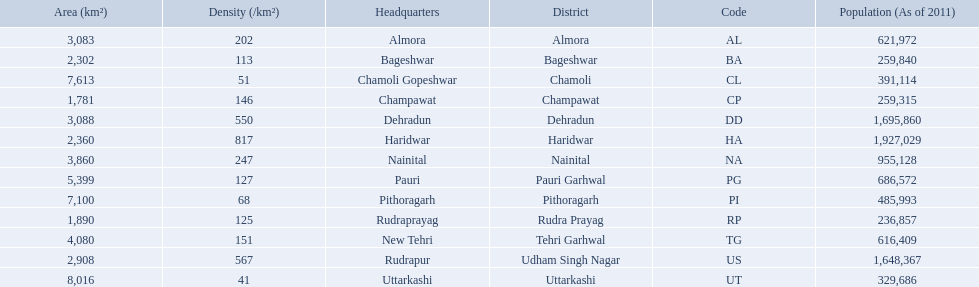What are the values for density of the districts of uttrakhand? 202, 113, 51, 146, 550, 817, 247, 127, 68, 125, 151, 567, 41. Which district has value of 51? Chamoli. 